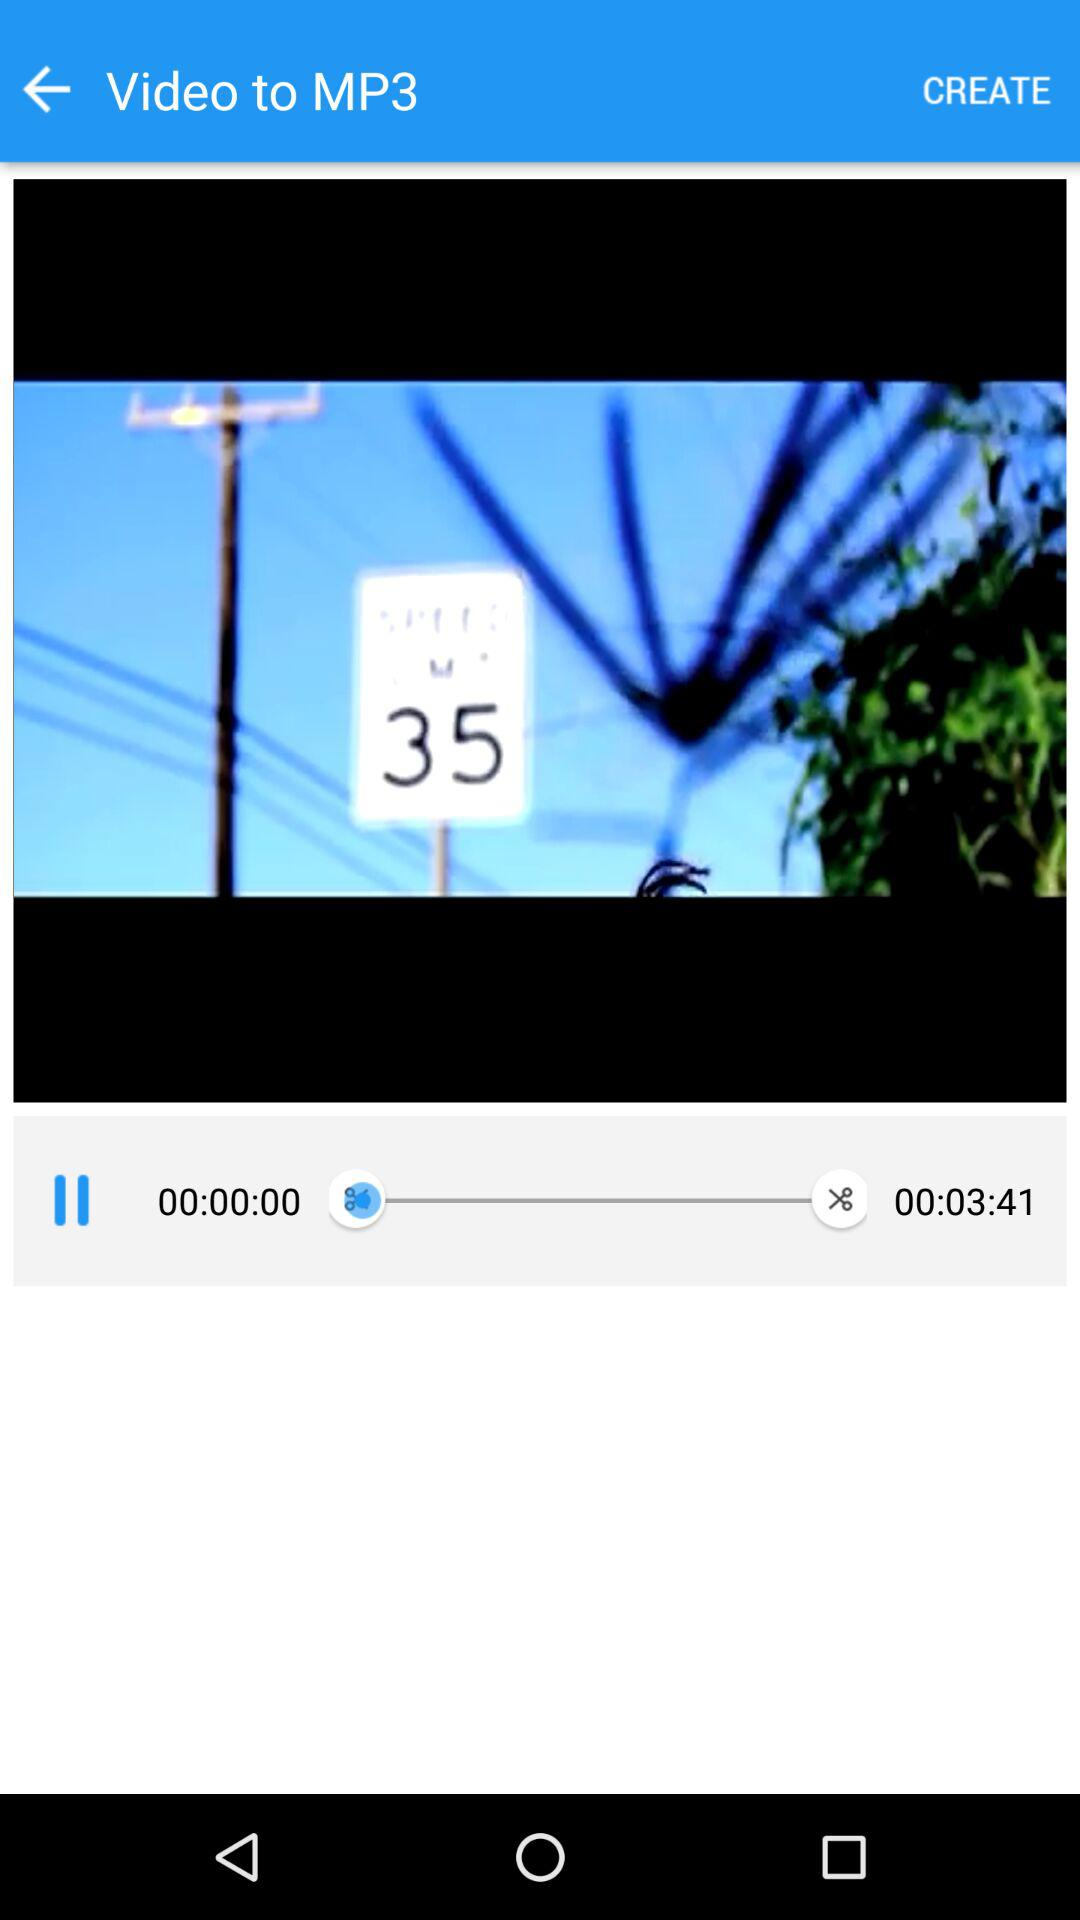Who posted this video?
When the provided information is insufficient, respond with <no answer>. <no answer> 